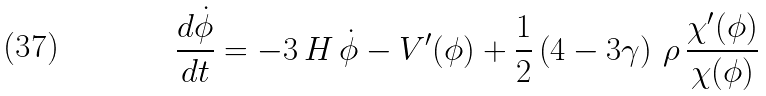Convert formula to latex. <formula><loc_0><loc_0><loc_500><loc_500>\frac { d \dot { \phi } } { d t } = - 3 \, H \, \dot { \phi } - V ^ { \prime } ( \phi ) + \frac { 1 } { 2 } \left ( 4 - 3 \gamma \right ) \, \rho \, \frac { \chi ^ { \prime } ( \phi ) } { \chi ( \phi ) }</formula> 